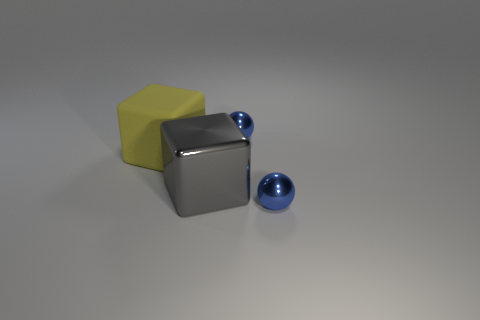There is a metallic thing that is behind the large block to the left of the big gray object that is to the right of the big rubber block; what is its shape? sphere 